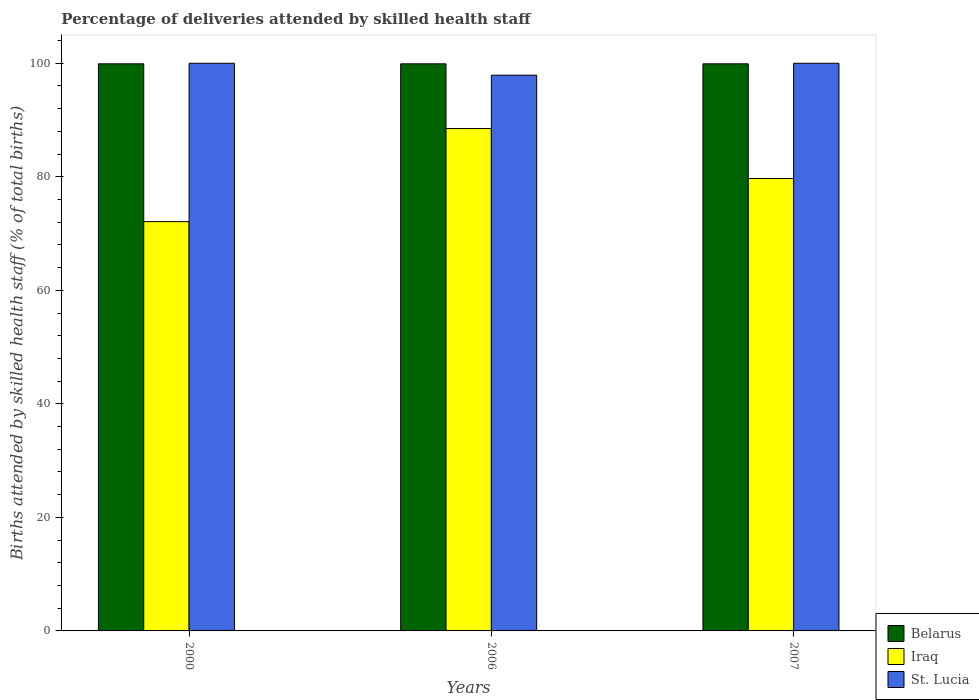How many bars are there on the 3rd tick from the right?
Your answer should be compact. 3. In how many cases, is the number of bars for a given year not equal to the number of legend labels?
Your response must be concise. 0. What is the percentage of births attended by skilled health staff in St. Lucia in 2006?
Ensure brevity in your answer.  97.9. Across all years, what is the minimum percentage of births attended by skilled health staff in Belarus?
Offer a terse response. 99.9. In which year was the percentage of births attended by skilled health staff in Iraq maximum?
Your answer should be compact. 2006. In which year was the percentage of births attended by skilled health staff in Iraq minimum?
Make the answer very short. 2000. What is the total percentage of births attended by skilled health staff in Iraq in the graph?
Ensure brevity in your answer.  240.3. What is the difference between the percentage of births attended by skilled health staff in Iraq in 2000 and the percentage of births attended by skilled health staff in Belarus in 2007?
Give a very brief answer. -27.8. What is the average percentage of births attended by skilled health staff in Belarus per year?
Make the answer very short. 99.9. In the year 2000, what is the difference between the percentage of births attended by skilled health staff in St. Lucia and percentage of births attended by skilled health staff in Belarus?
Your answer should be very brief. 0.1. In how many years, is the percentage of births attended by skilled health staff in Iraq greater than 44 %?
Make the answer very short. 3. What is the ratio of the percentage of births attended by skilled health staff in St. Lucia in 2000 to that in 2006?
Make the answer very short. 1.02. Is the percentage of births attended by skilled health staff in St. Lucia in 2000 less than that in 2006?
Make the answer very short. No. What is the difference between the highest and the lowest percentage of births attended by skilled health staff in St. Lucia?
Keep it short and to the point. 2.1. Is the sum of the percentage of births attended by skilled health staff in Iraq in 2000 and 2006 greater than the maximum percentage of births attended by skilled health staff in Belarus across all years?
Keep it short and to the point. Yes. What does the 1st bar from the left in 2007 represents?
Make the answer very short. Belarus. What does the 2nd bar from the right in 2000 represents?
Your response must be concise. Iraq. How many bars are there?
Your answer should be very brief. 9. How many years are there in the graph?
Keep it short and to the point. 3. Does the graph contain grids?
Offer a very short reply. No. Where does the legend appear in the graph?
Ensure brevity in your answer.  Bottom right. What is the title of the graph?
Ensure brevity in your answer.  Percentage of deliveries attended by skilled health staff. What is the label or title of the Y-axis?
Offer a terse response. Births attended by skilled health staff (% of total births). What is the Births attended by skilled health staff (% of total births) of Belarus in 2000?
Your answer should be very brief. 99.9. What is the Births attended by skilled health staff (% of total births) in Iraq in 2000?
Your answer should be compact. 72.1. What is the Births attended by skilled health staff (% of total births) of Belarus in 2006?
Make the answer very short. 99.9. What is the Births attended by skilled health staff (% of total births) of Iraq in 2006?
Keep it short and to the point. 88.5. What is the Births attended by skilled health staff (% of total births) in St. Lucia in 2006?
Your answer should be very brief. 97.9. What is the Births attended by skilled health staff (% of total births) of Belarus in 2007?
Your answer should be very brief. 99.9. What is the Births attended by skilled health staff (% of total births) in Iraq in 2007?
Your answer should be very brief. 79.7. What is the Births attended by skilled health staff (% of total births) of St. Lucia in 2007?
Keep it short and to the point. 100. Across all years, what is the maximum Births attended by skilled health staff (% of total births) of Belarus?
Give a very brief answer. 99.9. Across all years, what is the maximum Births attended by skilled health staff (% of total births) in Iraq?
Offer a terse response. 88.5. Across all years, what is the maximum Births attended by skilled health staff (% of total births) of St. Lucia?
Provide a succinct answer. 100. Across all years, what is the minimum Births attended by skilled health staff (% of total births) of Belarus?
Offer a terse response. 99.9. Across all years, what is the minimum Births attended by skilled health staff (% of total births) of Iraq?
Your answer should be compact. 72.1. Across all years, what is the minimum Births attended by skilled health staff (% of total births) of St. Lucia?
Your answer should be compact. 97.9. What is the total Births attended by skilled health staff (% of total births) in Belarus in the graph?
Keep it short and to the point. 299.7. What is the total Births attended by skilled health staff (% of total births) in Iraq in the graph?
Your response must be concise. 240.3. What is the total Births attended by skilled health staff (% of total births) of St. Lucia in the graph?
Your answer should be compact. 297.9. What is the difference between the Births attended by skilled health staff (% of total births) of Belarus in 2000 and that in 2006?
Make the answer very short. 0. What is the difference between the Births attended by skilled health staff (% of total births) of Iraq in 2000 and that in 2006?
Offer a very short reply. -16.4. What is the difference between the Births attended by skilled health staff (% of total births) of St. Lucia in 2000 and that in 2006?
Your response must be concise. 2.1. What is the difference between the Births attended by skilled health staff (% of total births) of Iraq in 2000 and that in 2007?
Offer a terse response. -7.6. What is the difference between the Births attended by skilled health staff (% of total births) in St. Lucia in 2000 and that in 2007?
Your response must be concise. 0. What is the difference between the Births attended by skilled health staff (% of total births) of Belarus in 2000 and the Births attended by skilled health staff (% of total births) of Iraq in 2006?
Keep it short and to the point. 11.4. What is the difference between the Births attended by skilled health staff (% of total births) of Iraq in 2000 and the Births attended by skilled health staff (% of total births) of St. Lucia in 2006?
Offer a very short reply. -25.8. What is the difference between the Births attended by skilled health staff (% of total births) in Belarus in 2000 and the Births attended by skilled health staff (% of total births) in Iraq in 2007?
Keep it short and to the point. 20.2. What is the difference between the Births attended by skilled health staff (% of total births) in Iraq in 2000 and the Births attended by skilled health staff (% of total births) in St. Lucia in 2007?
Provide a short and direct response. -27.9. What is the difference between the Births attended by skilled health staff (% of total births) in Belarus in 2006 and the Births attended by skilled health staff (% of total births) in Iraq in 2007?
Ensure brevity in your answer.  20.2. What is the difference between the Births attended by skilled health staff (% of total births) of Belarus in 2006 and the Births attended by skilled health staff (% of total births) of St. Lucia in 2007?
Offer a very short reply. -0.1. What is the average Births attended by skilled health staff (% of total births) in Belarus per year?
Ensure brevity in your answer.  99.9. What is the average Births attended by skilled health staff (% of total births) of Iraq per year?
Offer a terse response. 80.1. What is the average Births attended by skilled health staff (% of total births) of St. Lucia per year?
Ensure brevity in your answer.  99.3. In the year 2000, what is the difference between the Births attended by skilled health staff (% of total births) in Belarus and Births attended by skilled health staff (% of total births) in Iraq?
Your response must be concise. 27.8. In the year 2000, what is the difference between the Births attended by skilled health staff (% of total births) of Belarus and Births attended by skilled health staff (% of total births) of St. Lucia?
Ensure brevity in your answer.  -0.1. In the year 2000, what is the difference between the Births attended by skilled health staff (% of total births) of Iraq and Births attended by skilled health staff (% of total births) of St. Lucia?
Your answer should be compact. -27.9. In the year 2006, what is the difference between the Births attended by skilled health staff (% of total births) of Belarus and Births attended by skilled health staff (% of total births) of Iraq?
Make the answer very short. 11.4. In the year 2006, what is the difference between the Births attended by skilled health staff (% of total births) in Iraq and Births attended by skilled health staff (% of total births) in St. Lucia?
Your answer should be compact. -9.4. In the year 2007, what is the difference between the Births attended by skilled health staff (% of total births) of Belarus and Births attended by skilled health staff (% of total births) of Iraq?
Provide a short and direct response. 20.2. In the year 2007, what is the difference between the Births attended by skilled health staff (% of total births) in Iraq and Births attended by skilled health staff (% of total births) in St. Lucia?
Keep it short and to the point. -20.3. What is the ratio of the Births attended by skilled health staff (% of total births) in Iraq in 2000 to that in 2006?
Your answer should be very brief. 0.81. What is the ratio of the Births attended by skilled health staff (% of total births) of St. Lucia in 2000 to that in 2006?
Ensure brevity in your answer.  1.02. What is the ratio of the Births attended by skilled health staff (% of total births) in Belarus in 2000 to that in 2007?
Keep it short and to the point. 1. What is the ratio of the Births attended by skilled health staff (% of total births) in Iraq in 2000 to that in 2007?
Give a very brief answer. 0.9. What is the ratio of the Births attended by skilled health staff (% of total births) of Belarus in 2006 to that in 2007?
Your answer should be compact. 1. What is the ratio of the Births attended by skilled health staff (% of total births) of Iraq in 2006 to that in 2007?
Offer a terse response. 1.11. What is the ratio of the Births attended by skilled health staff (% of total births) of St. Lucia in 2006 to that in 2007?
Make the answer very short. 0.98. What is the difference between the highest and the second highest Births attended by skilled health staff (% of total births) of Belarus?
Give a very brief answer. 0. What is the difference between the highest and the second highest Births attended by skilled health staff (% of total births) of Iraq?
Provide a short and direct response. 8.8. What is the difference between the highest and the second highest Births attended by skilled health staff (% of total births) of St. Lucia?
Ensure brevity in your answer.  0. 